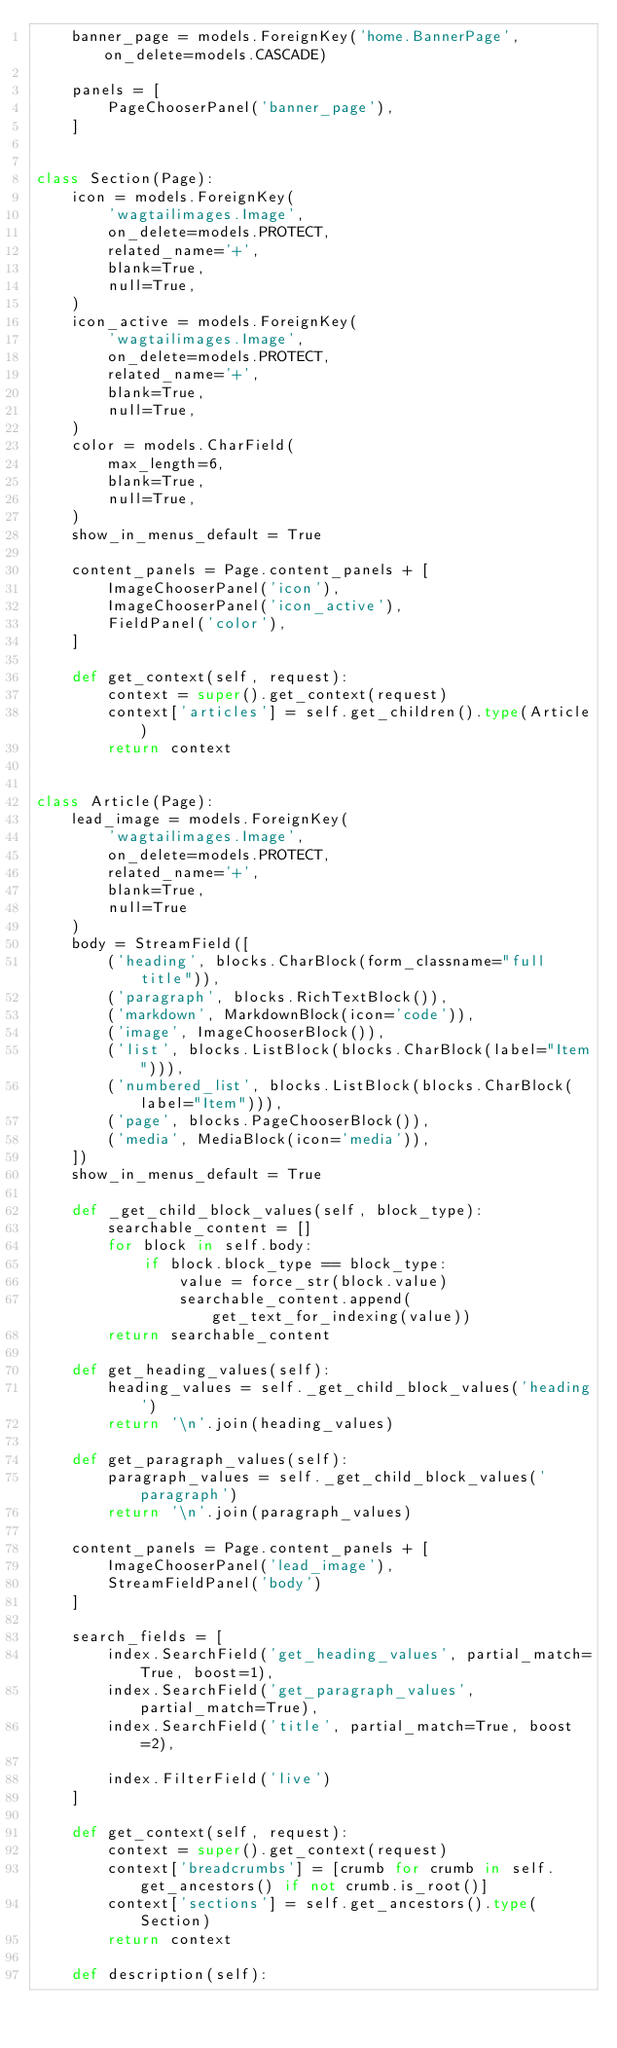<code> <loc_0><loc_0><loc_500><loc_500><_Python_>    banner_page = models.ForeignKey('home.BannerPage', on_delete=models.CASCADE)

    panels = [
        PageChooserPanel('banner_page'),
    ]


class Section(Page):
    icon = models.ForeignKey(
        'wagtailimages.Image',
        on_delete=models.PROTECT,
        related_name='+',
        blank=True,
        null=True,
    )
    icon_active = models.ForeignKey(
        'wagtailimages.Image',
        on_delete=models.PROTECT,
        related_name='+',
        blank=True,
        null=True,
    )
    color = models.CharField(
        max_length=6,
        blank=True,
        null=True,
    )
    show_in_menus_default = True

    content_panels = Page.content_panels + [
        ImageChooserPanel('icon'),
        ImageChooserPanel('icon_active'),
        FieldPanel('color'),
    ]

    def get_context(self, request):
        context = super().get_context(request)
        context['articles'] = self.get_children().type(Article)
        return context


class Article(Page):
    lead_image = models.ForeignKey(
        'wagtailimages.Image',
        on_delete=models.PROTECT,
        related_name='+',
        blank=True,
        null=True
    )
    body = StreamField([
        ('heading', blocks.CharBlock(form_classname="full title")),
        ('paragraph', blocks.RichTextBlock()),
        ('markdown', MarkdownBlock(icon='code')),
        ('image', ImageChooserBlock()),
        ('list', blocks.ListBlock(blocks.CharBlock(label="Item"))),
        ('numbered_list', blocks.ListBlock(blocks.CharBlock(label="Item"))),
        ('page', blocks.PageChooserBlock()),
        ('media', MediaBlock(icon='media')),
    ])
    show_in_menus_default = True

    def _get_child_block_values(self, block_type):
        searchable_content = []
        for block in self.body:
            if block.block_type == block_type:
                value = force_str(block.value)
                searchable_content.append(get_text_for_indexing(value))
        return searchable_content

    def get_heading_values(self):
        heading_values = self._get_child_block_values('heading')
        return '\n'.join(heading_values)

    def get_paragraph_values(self):
        paragraph_values = self._get_child_block_values('paragraph')
        return '\n'.join(paragraph_values)

    content_panels = Page.content_panels + [
        ImageChooserPanel('lead_image'),
        StreamFieldPanel('body')
    ]

    search_fields = [
        index.SearchField('get_heading_values', partial_match=True, boost=1),
        index.SearchField('get_paragraph_values', partial_match=True),
        index.SearchField('title', partial_match=True, boost=2),

        index.FilterField('live')
    ]

    def get_context(self, request):
        context = super().get_context(request)
        context['breadcrumbs'] = [crumb for crumb in self.get_ancestors() if not crumb.is_root()]
        context['sections'] = self.get_ancestors().type(Section)
        return context

    def description(self):</code> 